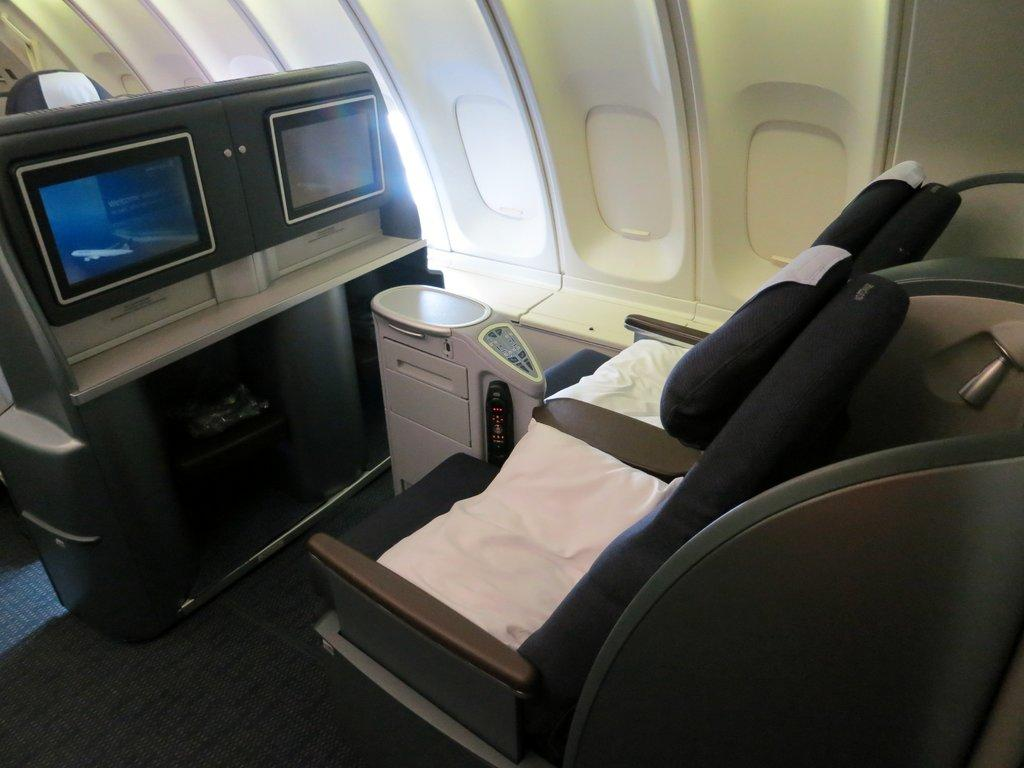What part of a vehicle is shown in the image? The image shows the inner part of a vehicle. How many seats are visible in the image? There are two seats visible in the image. What is located in front of the seats? There are two screens in front of the seats. What type of soap is used to clean the seats in the image? There is no soap present in the image, as it focuses on the interior of the vehicle and its features. 